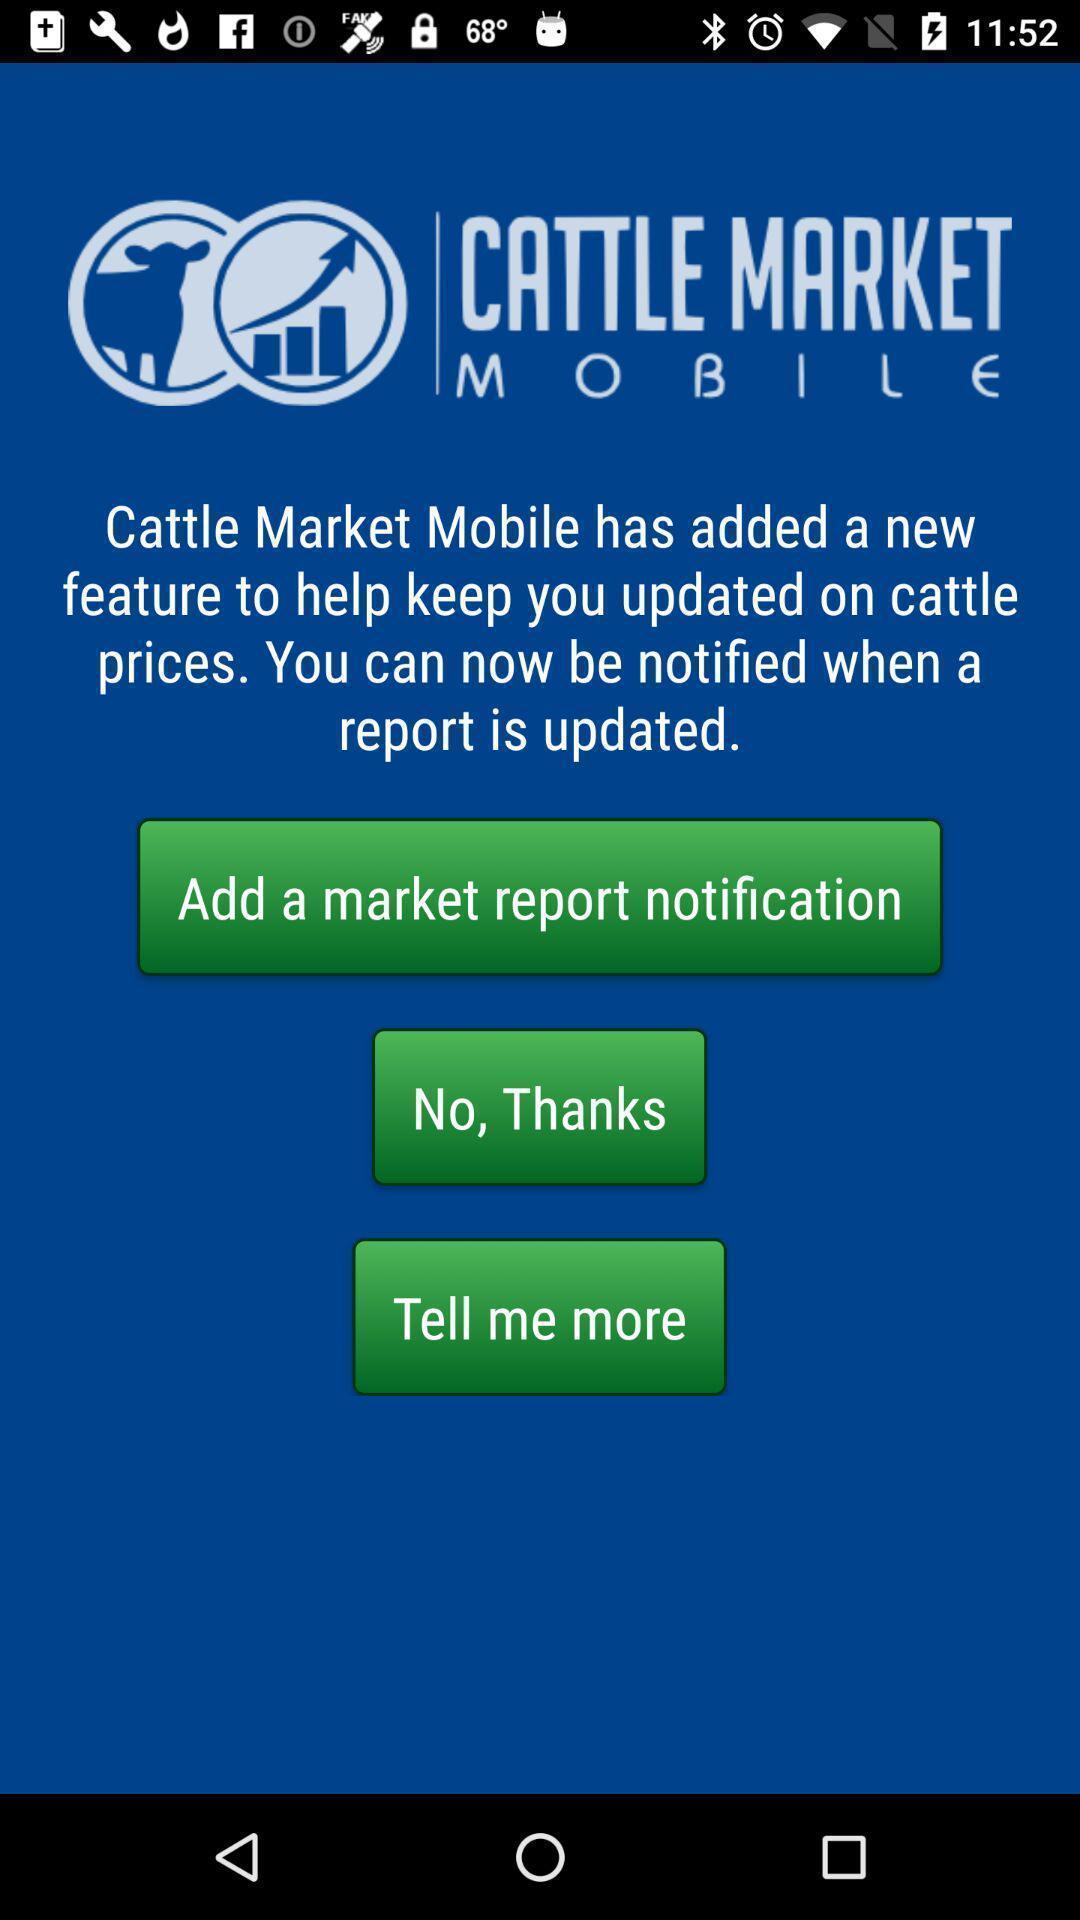Describe this image in words. Welcome page displaying about market with different options. 